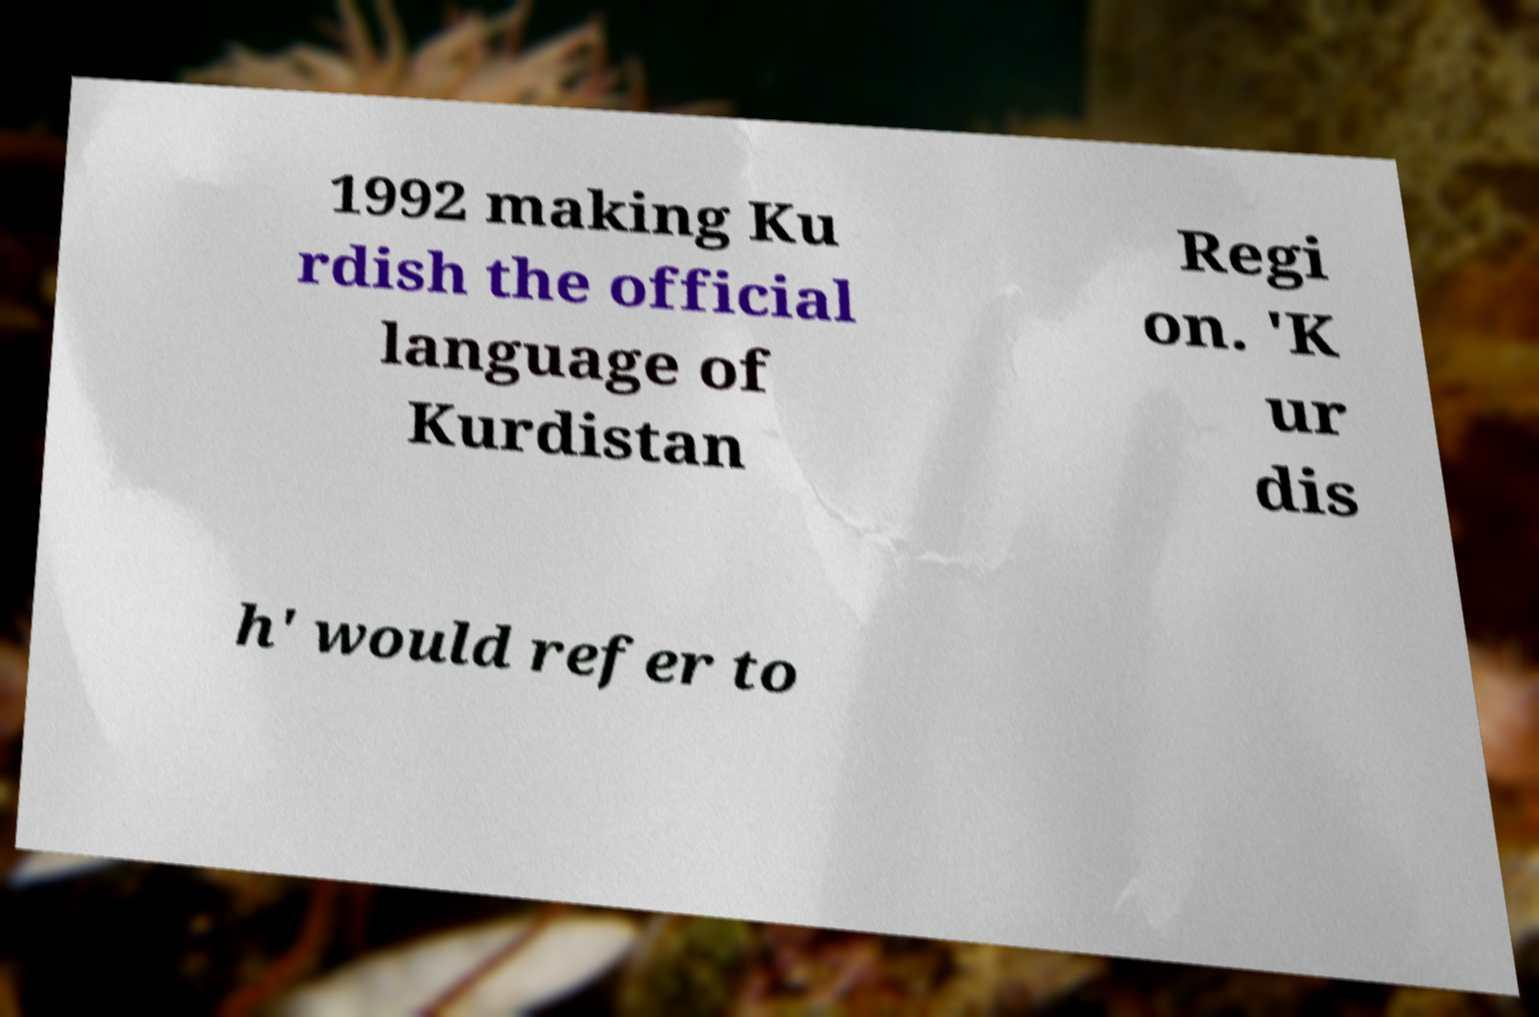Please identify and transcribe the text found in this image. 1992 making Ku rdish the official language of Kurdistan Regi on. 'K ur dis h' would refer to 